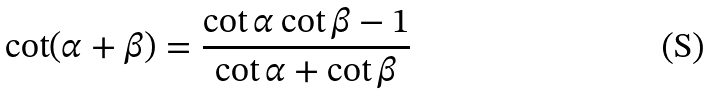<formula> <loc_0><loc_0><loc_500><loc_500>\cot ( \alpha + \beta ) = { \frac { \cot \alpha \cot \beta - 1 } { \cot \alpha + \cot \beta } }</formula> 